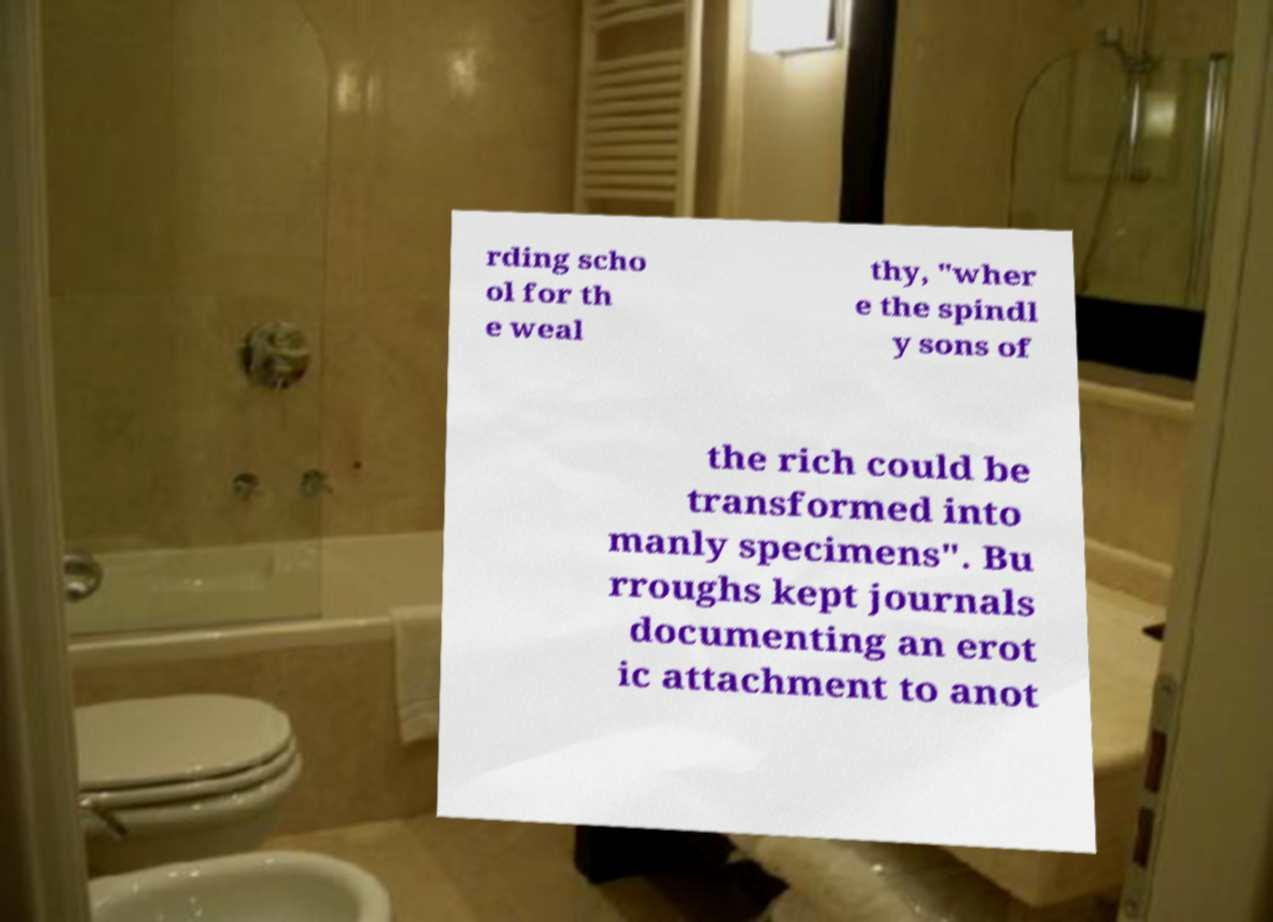Please identify and transcribe the text found in this image. rding scho ol for th e weal thy, "wher e the spindl y sons of the rich could be transformed into manly specimens". Bu rroughs kept journals documenting an erot ic attachment to anot 